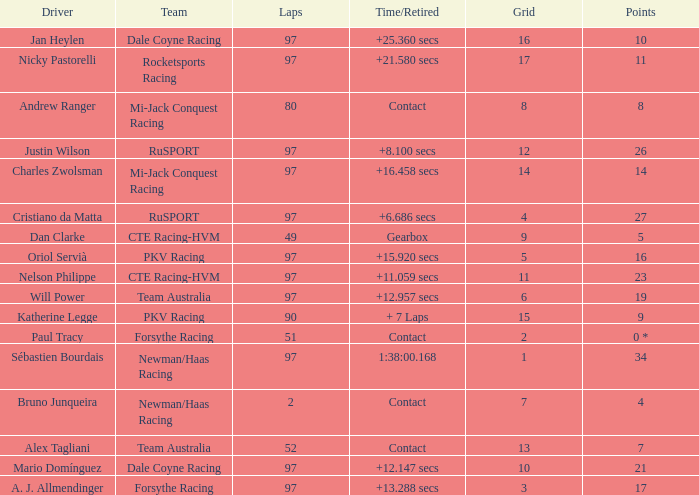What team does jan heylen race for? Dale Coyne Racing. 